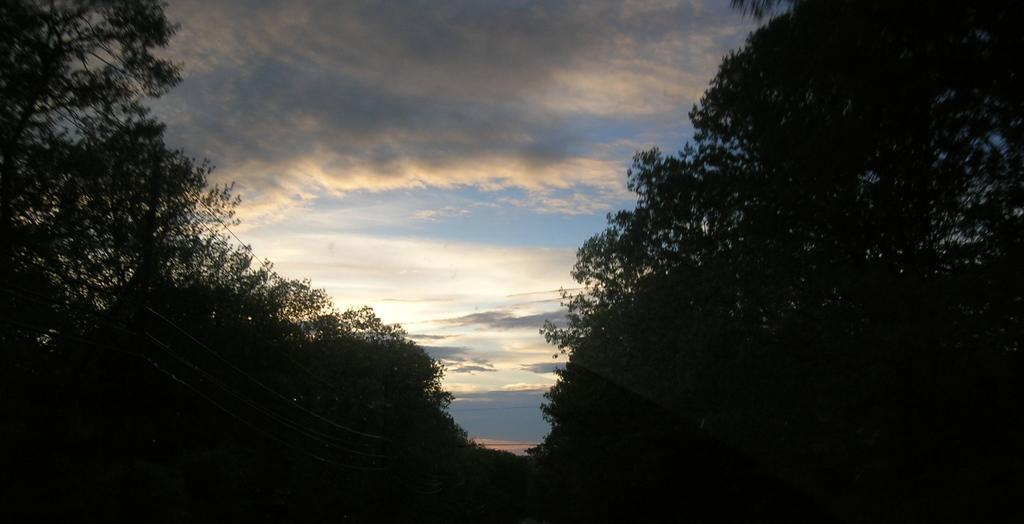What type of vegetation can be seen in the image? There are trees in the image. What else is present in the image besides trees? There are wires in the image. What can be seen in the background of the image? The sky is visible in the background of the image. How would you describe the sky in the image? The sky is cloudy in the image. How would you describe the overall lighting in the image? The image appears to be dark. Can you see a scarf being used to crush a quiver in the image? There is no scarf, crush, or quiver present in the image. 